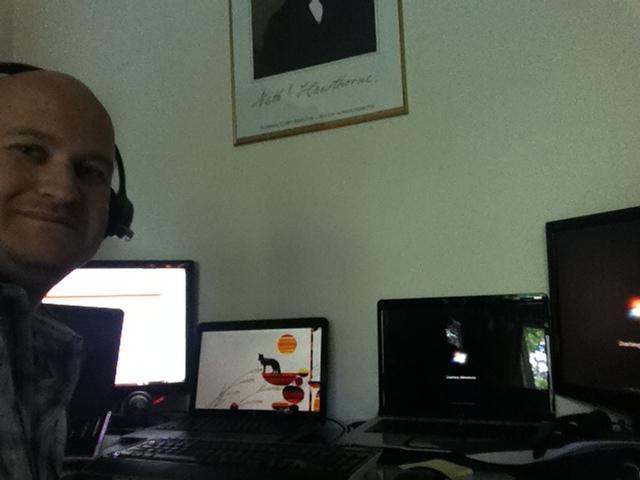How many of the computer monitors have anti-glare screens?
Give a very brief answer. 3. How many pictures on the wall?
Give a very brief answer. 1. How many laptops are in the picture?
Give a very brief answer. 2. How many tvs are in the picture?
Give a very brief answer. 4. How many suitcases are there?
Give a very brief answer. 0. 